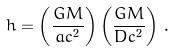<formula> <loc_0><loc_0><loc_500><loc_500>h = \left ( \frac { G M } { a c ^ { 2 } } \right ) \left ( \frac { G M } { D c ^ { 2 } } \right ) \, .</formula> 